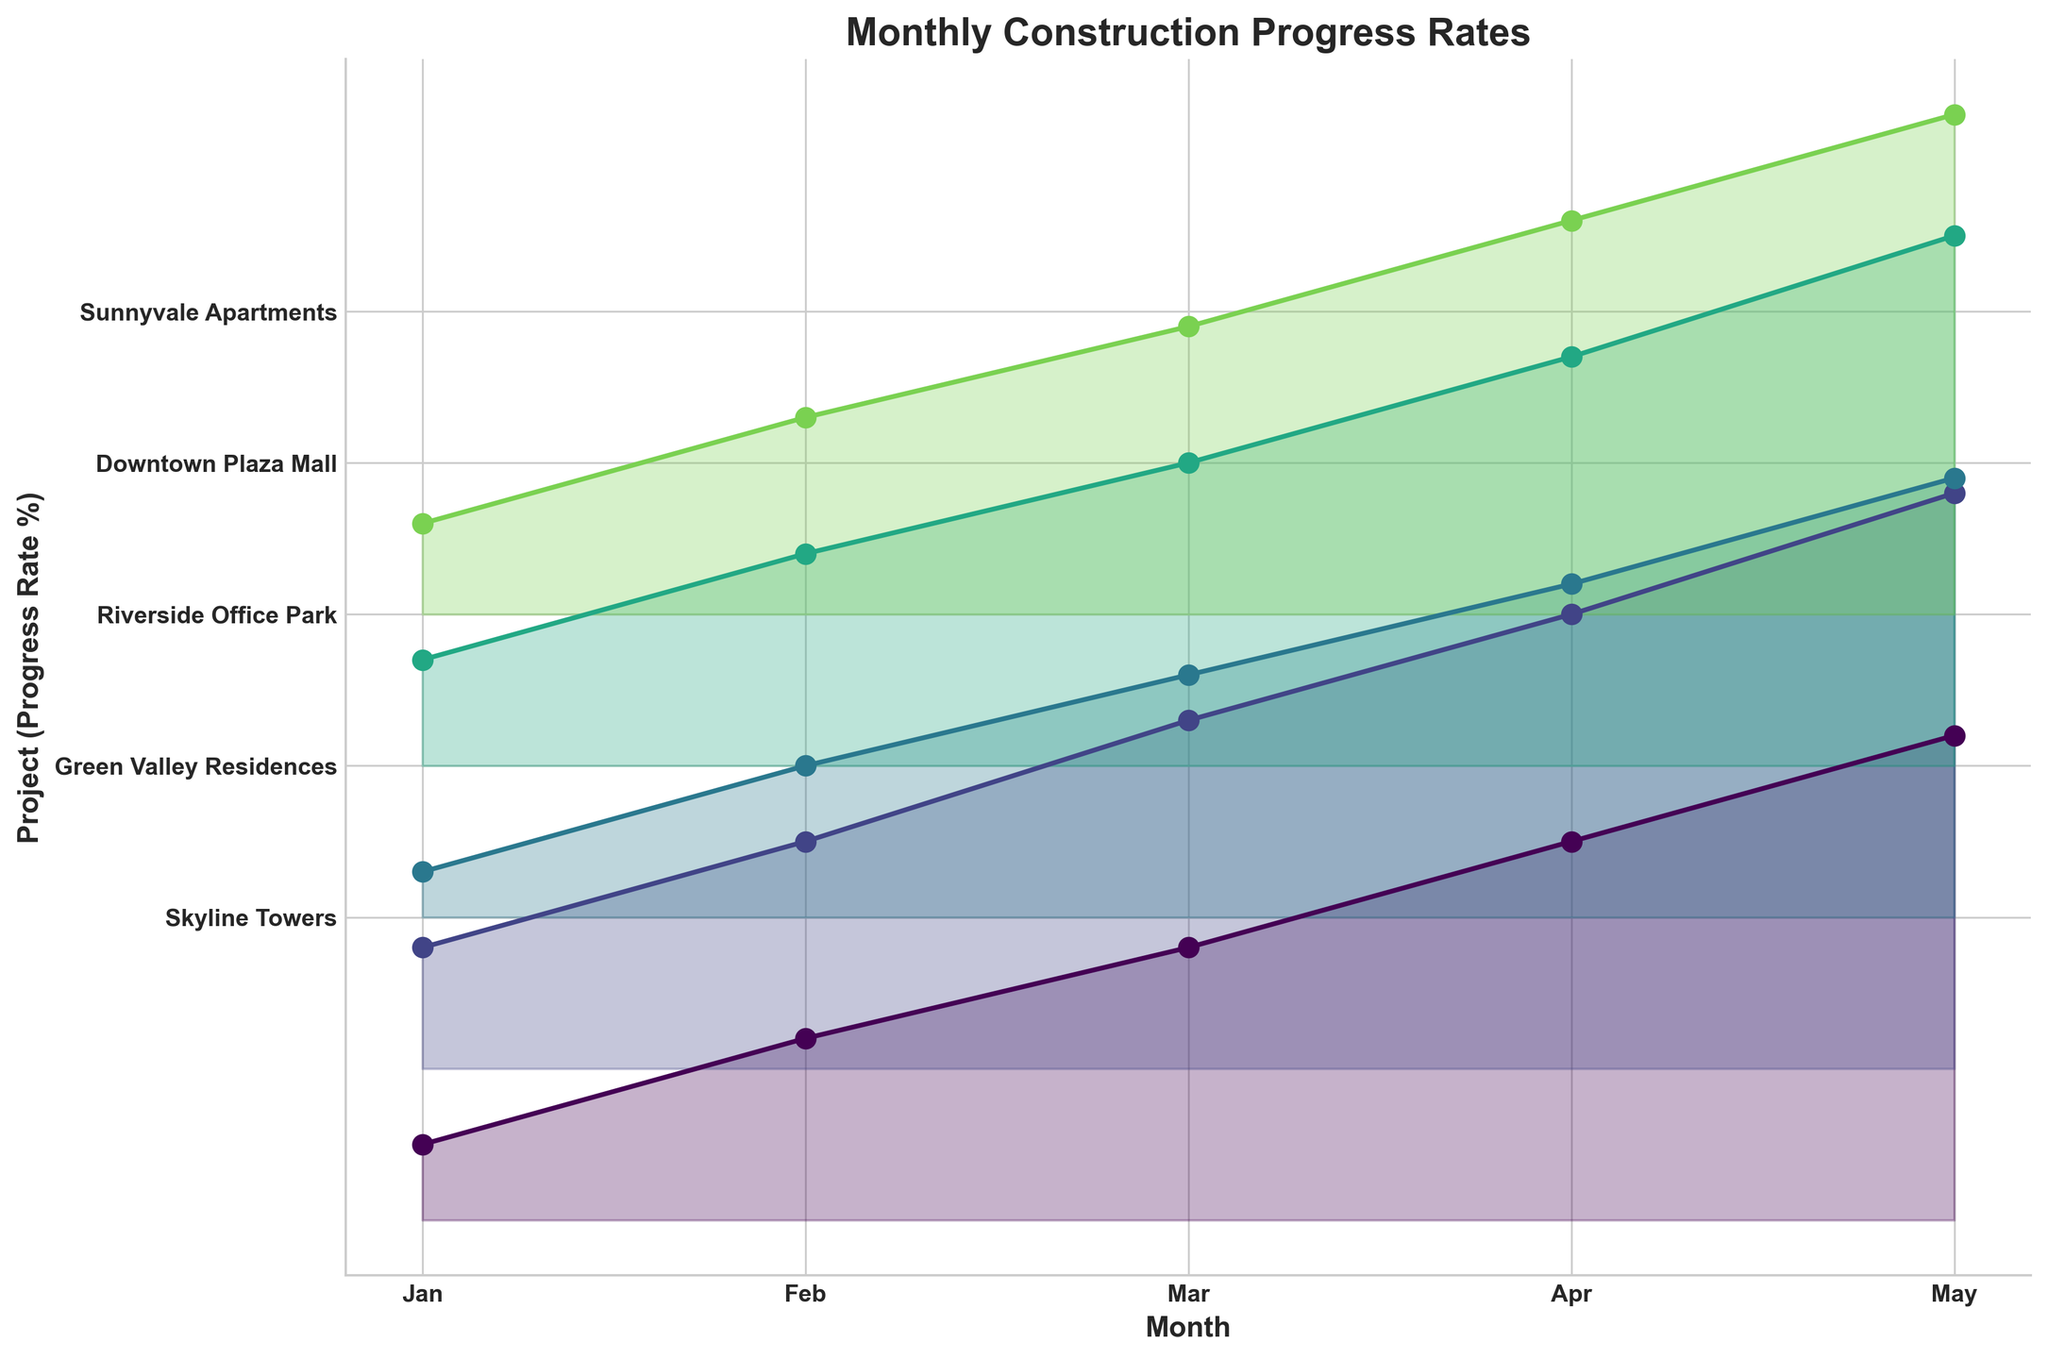what is the title of the figure? The title of the figure is located at the top and is usually in a larger, bold font. It provides a brief summary of what the plot is about. The title in this plot is "Monthly Construction Progress Rates".
Answer: Monthly Construction Progress Rates which project has the highest construction progress rate in May? To identify the highest construction progress rate in May, look at the values for each project in May and compare them. The highest value is for Green Valley Residences, which is 38%.
Answer: Green Valley Residences how does the progress rate for Riverside Office Park in February compare to Sunnyvale Apartments in February? To compare the progress rates, locate the values for Riverside Office Park and Sunnyvale Apartments in February. Riverside Office Park has a progress rate of 10%, while Sunnyvale Apartments has 13%. Therefore, Sunnyvale Apartments has a higher progress rate in February.
Answer: Sunnyvale Apartments is higher what's the average construction progress rate for Skyline Towers across all months? Calculate the average by summing the progress rates for Skyline Towers across all months (5 + 12 + 18 + 25 + 32) and then dividing by the number of months (5). The sum is 92, so the average progress rate is 92 / 5 = 18.4%.
Answer: 18.4% which month shows the greatest increase in progress rate for Downtown Plaza Mall? To identify the greatest increase, examine the monthly progress rates for Downtown Plaza Mall and find the largest difference between consecutive months. The differences are (14 - 7) = 7, (20 - 14) = 6, (27 - 20) = 7, and (35 - 27) = 8. The greatest increase is between April and May, with an 8% increase.
Answer: Between April and May what is the comparison of construction progress rates between Green Valley Residences and Downtown Plaza Mall in April? Look at the construction progress rates for both Green Valley Residences and Downtown Plaza Mall in April. Green Valley Residences has a rate of 30%, and Downtown Plaza Mall has 27%. So Green Valley Residences has a slightly higher rate in April.
Answer: Green Valley Residences is higher what is the difference between the highest and lowest progress rates across all projects in March? Identify the progress rates for all projects in March: Skyline Towers (18), Green Valley Residences (23), Riverside Office Park (16), Downtown Plaza Mall (20), and Sunnyvale Apartments (19). The highest rate is 23%, and the lowest is 16%. The difference is 23 - 16 = 7%.
Answer: 7% which project completed its construction most quickly within the given months? To determine which project completed fastest, observe which project reached the highest progress rate by May. Green Valley Residences reached 38%, the highest progress rate among the projects.
Answer: Green Valley Residences what trend can be observed in the construction progress rates for Sunnyvale Apartments from January to May? Observe the points plotted for Sunnyvale Apartments from January to May: 6%, 13%, 19%, 26%, and 33%. The trend shows a steady increase in progress rate each month.
Answer: Steady increase 